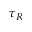<formula> <loc_0><loc_0><loc_500><loc_500>\tau _ { R }</formula> 